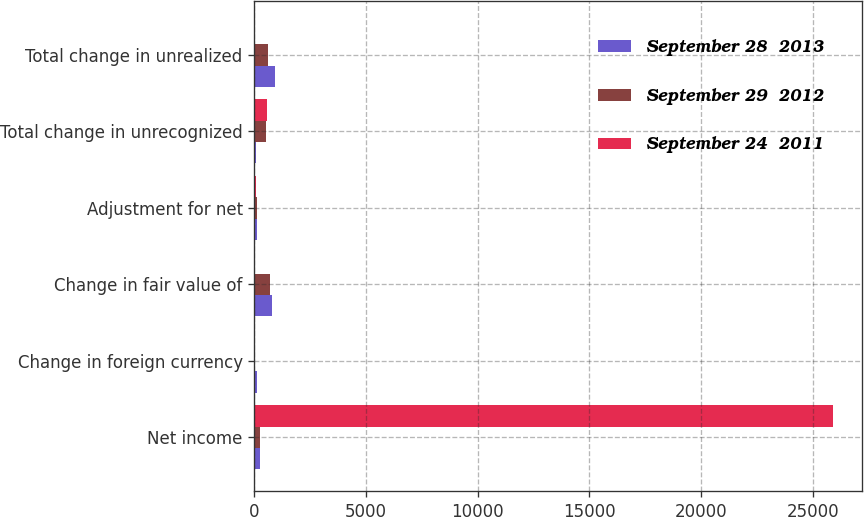Convert chart. <chart><loc_0><loc_0><loc_500><loc_500><stacked_bar_chart><ecel><fcel>Net income<fcel>Change in foreign currency<fcel>Change in fair value of<fcel>Adjustment for net<fcel>Total change in unrecognized<fcel>Total change in unrealized<nl><fcel>September 28  2013<fcel>265<fcel>112<fcel>791<fcel>131<fcel>64<fcel>922<nl><fcel>September 29  2012<fcel>265<fcel>15<fcel>715<fcel>114<fcel>530<fcel>601<nl><fcel>September 24  2011<fcel>25922<fcel>12<fcel>29<fcel>70<fcel>542<fcel>41<nl></chart> 